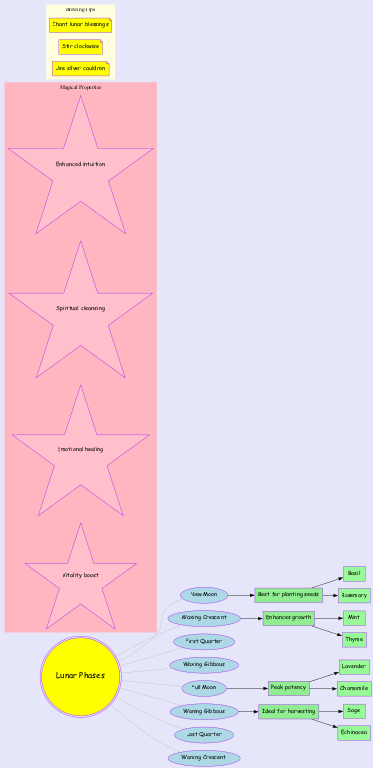What phase is best for planting seeds? The diagram shows that the New Moon phase is indicated as the best time for planting seeds. This information is directly connected to the "New Moon" node, which shows the effect associated with this phase.
Answer: New Moon Which herbs enhance growth during the Waxing Crescent? From the diagram, the Waxing Crescent phase indicates that the herbs associated with enhancing growth are Mint and Thyme. This information can be found in the herbs linked to the "Enhances growth" effect.
Answer: Mint, Thyme How many lunar phases are represented in the diagram? The diagram lists a total of eight distinct lunar phases. By counting the phases listed in the main section of the diagram, we reach this total.
Answer: 8 Which lunar phase has peak potency? According to the diagram, the Full Moon phase displays peak potency, as stated in the respective effect linked to this phase.
Answer: Full Moon What is an effect of the Waning Gibbous phase? The diagram shows that the effect of the Waning Gibbous phase is identified as "Ideal for harvesting." This information can be found directly under the Waning Gibbous node.
Answer: Ideal for harvesting What magical property is linked to emotional healing? The diagram lists magical properties; one of them is "Emotional healing." This property can be found in the section dedicated to magical properties within the diagram.
Answer: Emotional healing How many herbs are associated with the Full Moon phase? The Full Moon phase connects to two specific herbs, Lavender and Chamomile. By examining the herbs linked to the "Peak potency" effect, we find this number.
Answer: 2 What should you do while brewing according to the tips? The diagram states that one should "Stir clockwise" while brewing. This instruction is found within the brewing tips section of the diagram.
Answer: Stir clockwise Which plant can be harvested during the Waning Gibbous? The diagram indicates that Sage and Echinacea are the herbs that can be harvested during the Waning Gibbous phase. By checking the associated herbs for harvesting, we identify Sage.
Answer: Sage 